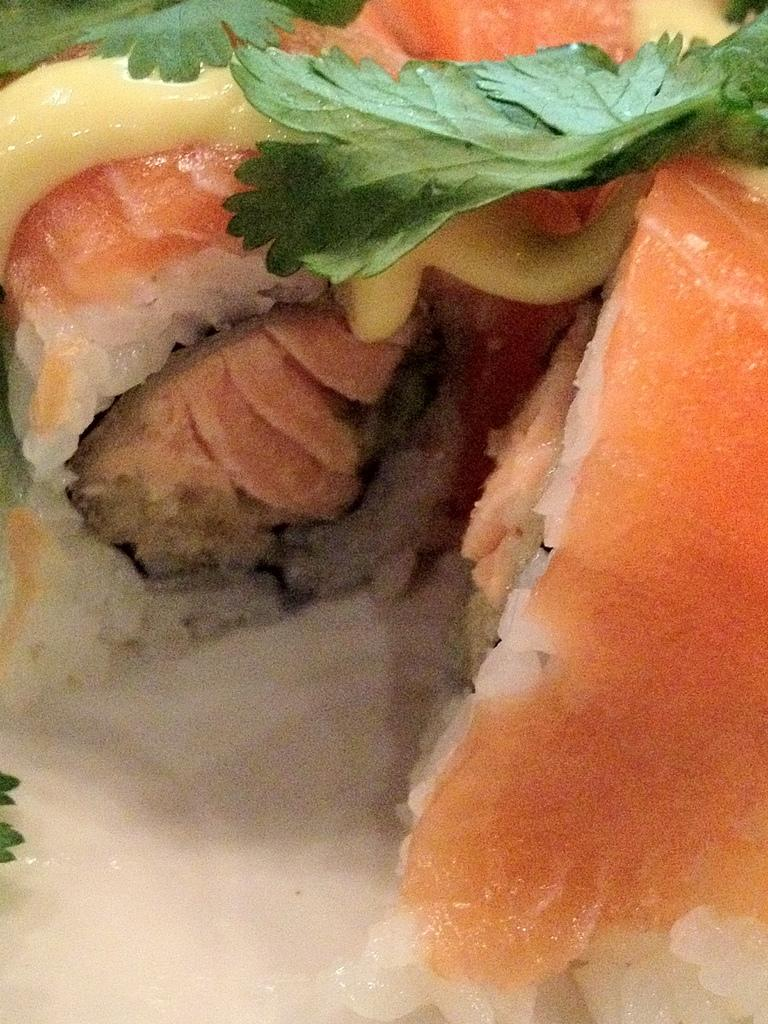What is the main subject of the image? There is a food item in the center of the image. What type of ingredients can be found in the food item? The food item contains meat and leaves. What type of sound does the food item make when it expands? The food item does not make any sound when it expands, as it is not a living or mechanical object that can produce sound. 